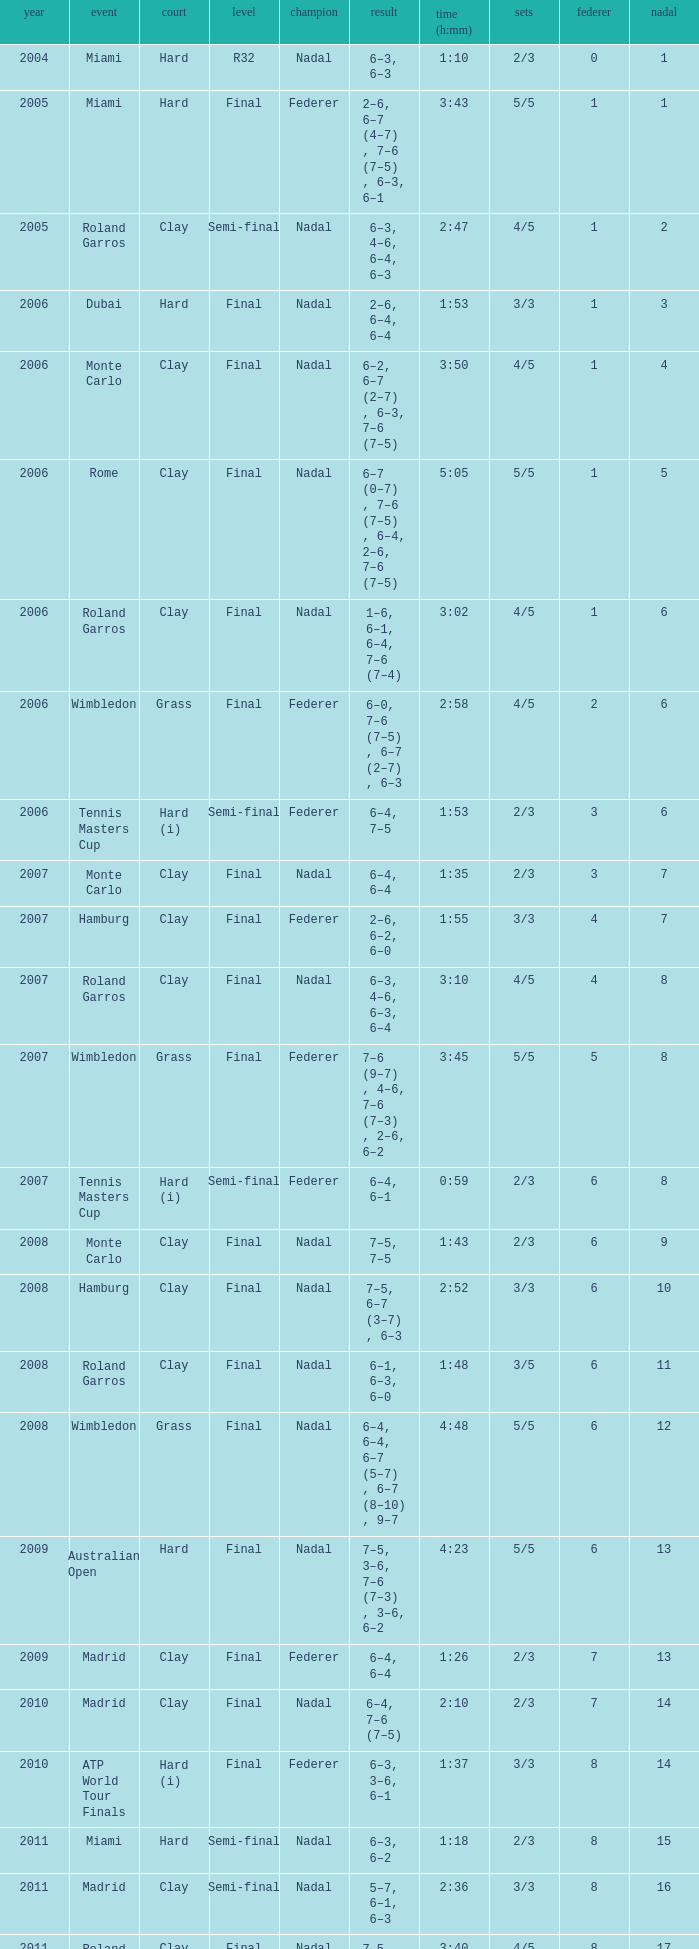What was the nadal in Miami in the final round? 1.0. 